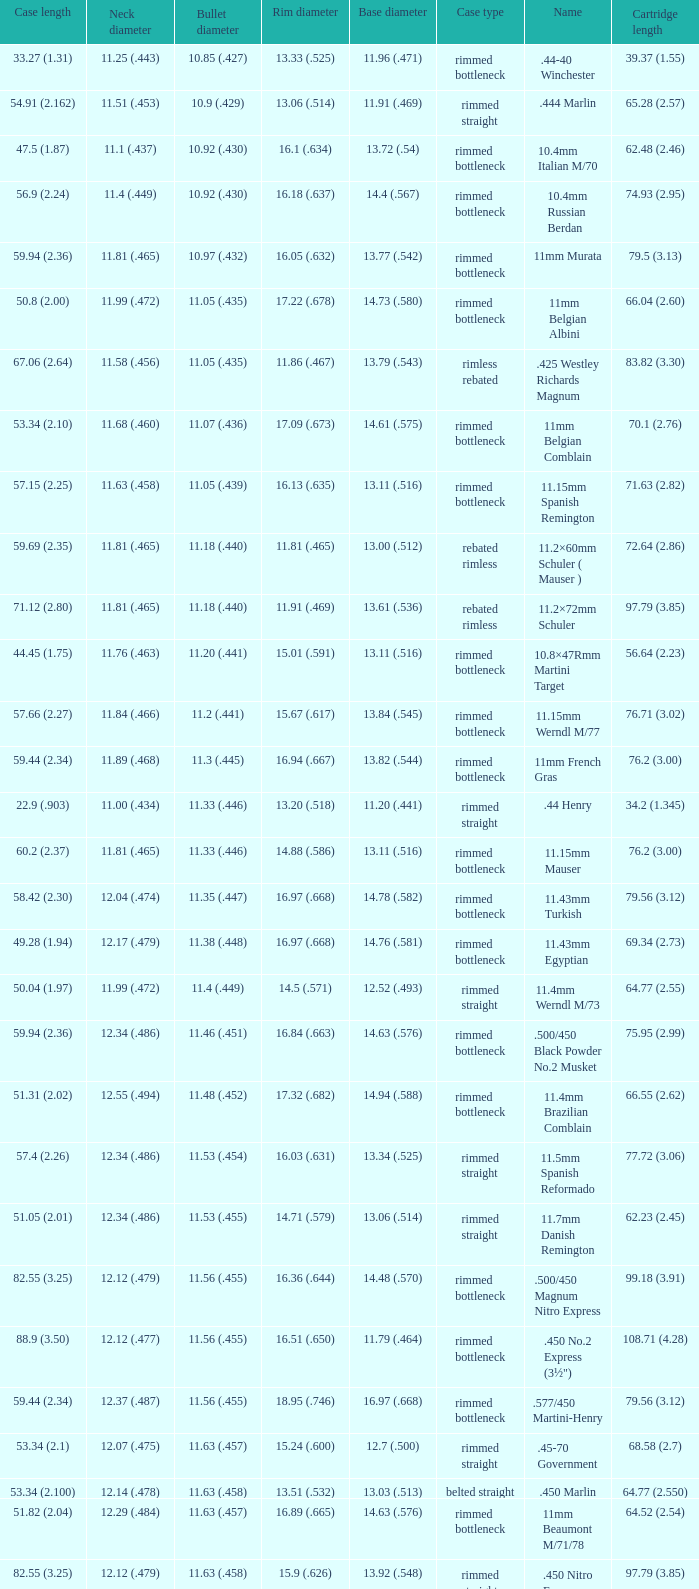Which Case length has a Rim diameter of 13.20 (.518)? 22.9 (.903). 